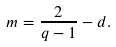Convert formula to latex. <formula><loc_0><loc_0><loc_500><loc_500>m = \frac { 2 } { q - 1 } - d .</formula> 